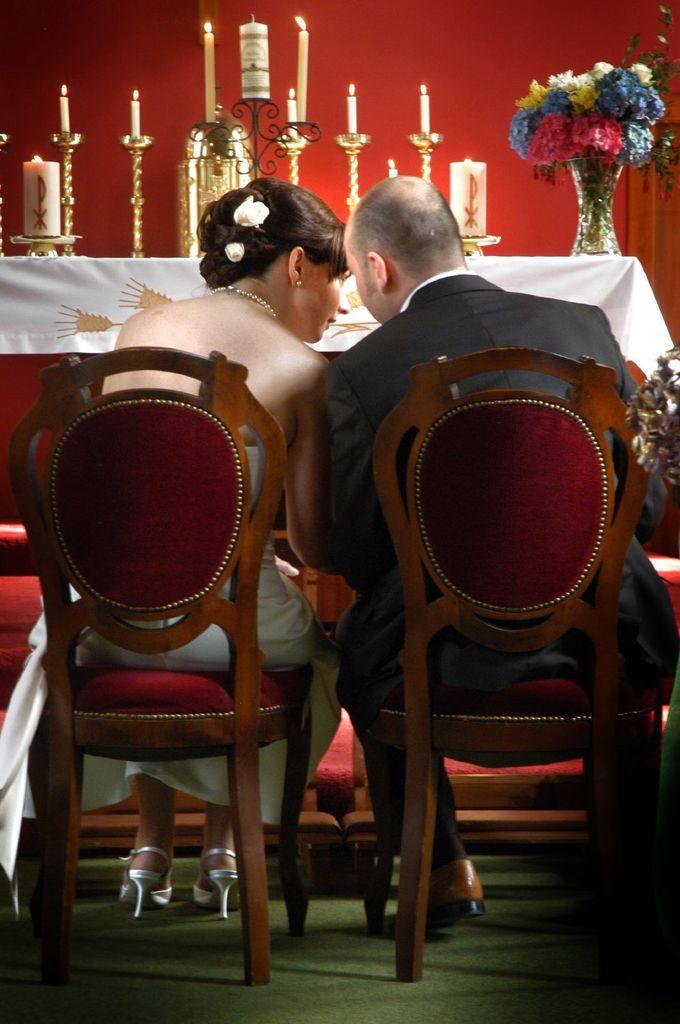In one or two sentences, can you explain what this image depicts? In this image I can see a couple sitting on the chair. In the background, I can see the candles and a flower flask on the table. 